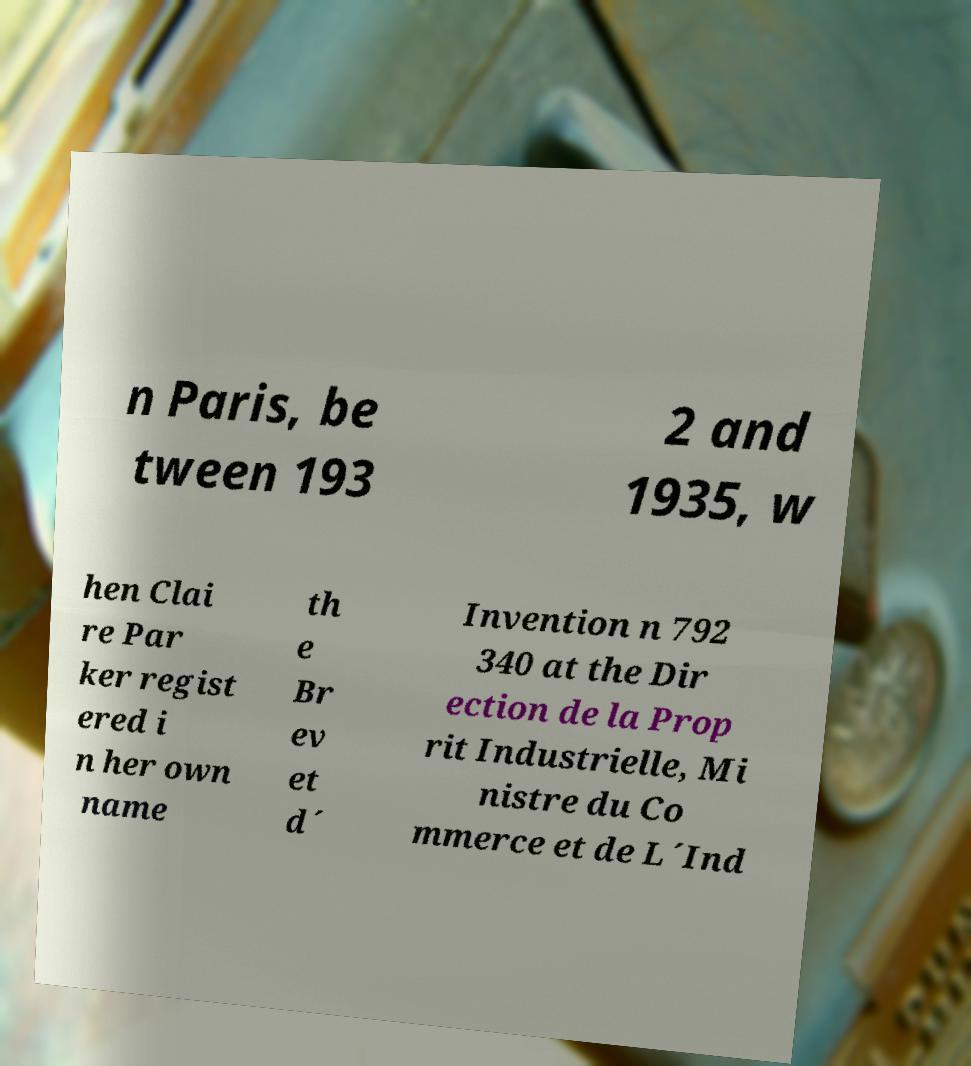Can you read and provide the text displayed in the image?This photo seems to have some interesting text. Can you extract and type it out for me? n Paris, be tween 193 2 and 1935, w hen Clai re Par ker regist ered i n her own name th e Br ev et d´ Invention n 792 340 at the Dir ection de la Prop rit Industrielle, Mi nistre du Co mmerce et de L´Ind 